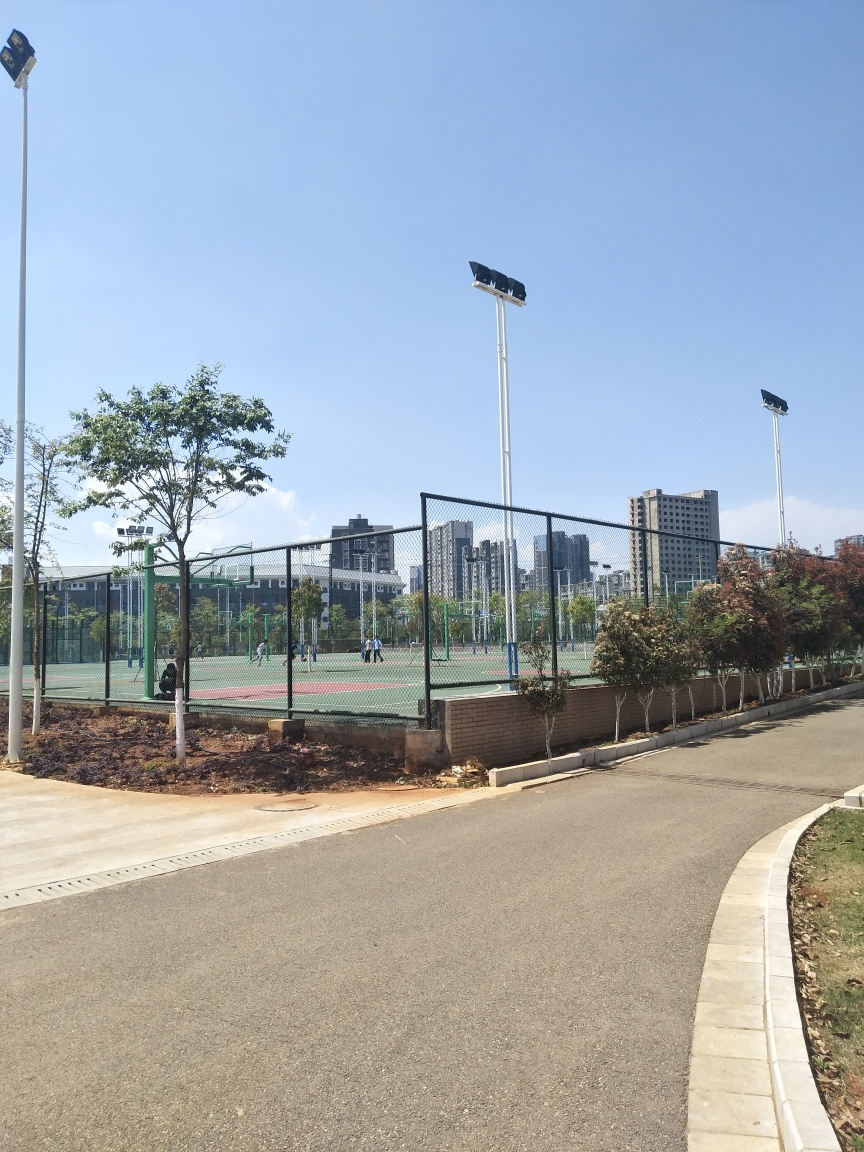Can you tell what time of day it might be in this image? Given the clear sky and the angle of the shadows cast by the light poles and trees, it seems to be either late morning or early afternoon. 